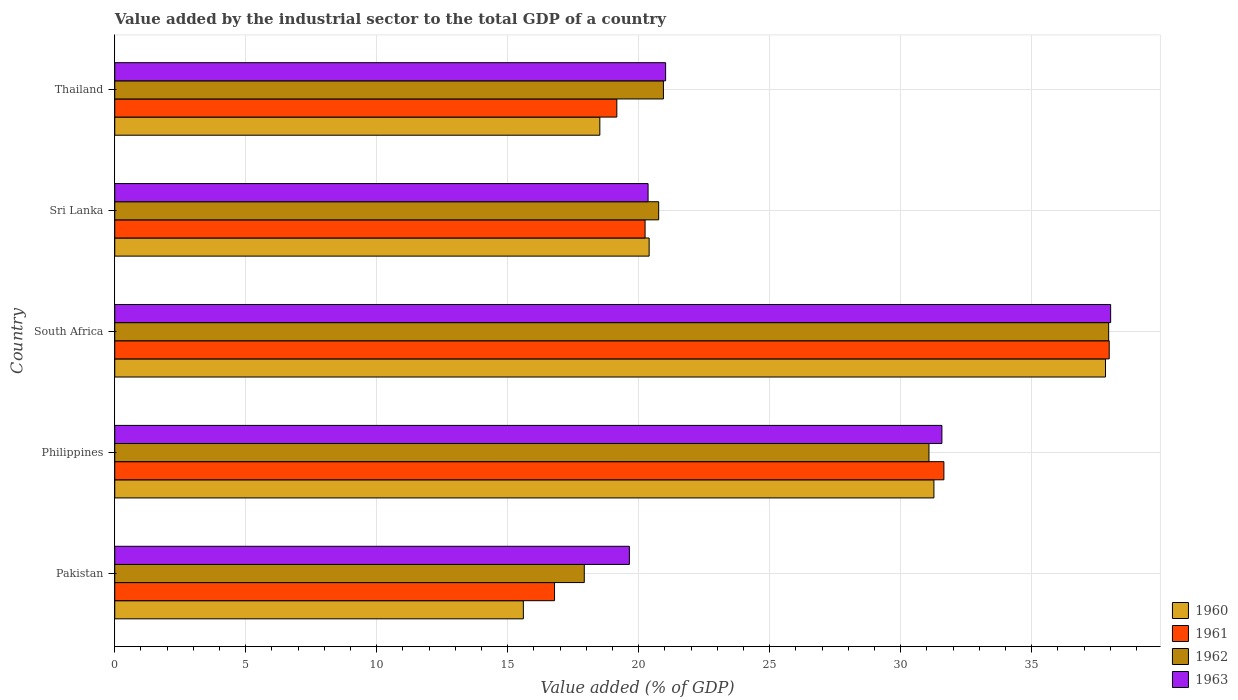How many different coloured bars are there?
Provide a succinct answer. 4. How many groups of bars are there?
Your answer should be compact. 5. Are the number of bars per tick equal to the number of legend labels?
Give a very brief answer. Yes. How many bars are there on the 3rd tick from the top?
Give a very brief answer. 4. How many bars are there on the 3rd tick from the bottom?
Keep it short and to the point. 4. What is the value added by the industrial sector to the total GDP in 1962 in Thailand?
Your answer should be very brief. 20.94. Across all countries, what is the maximum value added by the industrial sector to the total GDP in 1960?
Your response must be concise. 37.82. Across all countries, what is the minimum value added by the industrial sector to the total GDP in 1963?
Your answer should be very brief. 19.64. In which country was the value added by the industrial sector to the total GDP in 1962 maximum?
Offer a terse response. South Africa. In which country was the value added by the industrial sector to the total GDP in 1960 minimum?
Your response must be concise. Pakistan. What is the total value added by the industrial sector to the total GDP in 1962 in the graph?
Your answer should be compact. 128.64. What is the difference between the value added by the industrial sector to the total GDP in 1961 in Pakistan and that in Sri Lanka?
Provide a short and direct response. -3.46. What is the difference between the value added by the industrial sector to the total GDP in 1960 in Thailand and the value added by the industrial sector to the total GDP in 1962 in Pakistan?
Make the answer very short. 0.59. What is the average value added by the industrial sector to the total GDP in 1963 per country?
Provide a succinct answer. 26.12. What is the difference between the value added by the industrial sector to the total GDP in 1961 and value added by the industrial sector to the total GDP in 1960 in Pakistan?
Make the answer very short. 1.19. What is the ratio of the value added by the industrial sector to the total GDP in 1962 in Pakistan to that in Sri Lanka?
Offer a terse response. 0.86. Is the value added by the industrial sector to the total GDP in 1960 in South Africa less than that in Sri Lanka?
Make the answer very short. No. What is the difference between the highest and the second highest value added by the industrial sector to the total GDP in 1960?
Ensure brevity in your answer.  6.55. What is the difference between the highest and the lowest value added by the industrial sector to the total GDP in 1962?
Give a very brief answer. 20.02. Is it the case that in every country, the sum of the value added by the industrial sector to the total GDP in 1962 and value added by the industrial sector to the total GDP in 1963 is greater than the sum of value added by the industrial sector to the total GDP in 1961 and value added by the industrial sector to the total GDP in 1960?
Ensure brevity in your answer.  No. What does the 1st bar from the top in Thailand represents?
Your response must be concise. 1963. What does the 1st bar from the bottom in Thailand represents?
Give a very brief answer. 1960. Is it the case that in every country, the sum of the value added by the industrial sector to the total GDP in 1961 and value added by the industrial sector to the total GDP in 1960 is greater than the value added by the industrial sector to the total GDP in 1962?
Give a very brief answer. Yes. Are all the bars in the graph horizontal?
Provide a succinct answer. Yes. Are the values on the major ticks of X-axis written in scientific E-notation?
Make the answer very short. No. How many legend labels are there?
Make the answer very short. 4. How are the legend labels stacked?
Provide a succinct answer. Vertical. What is the title of the graph?
Your answer should be compact. Value added by the industrial sector to the total GDP of a country. Does "2012" appear as one of the legend labels in the graph?
Keep it short and to the point. No. What is the label or title of the X-axis?
Your response must be concise. Value added (% of GDP). What is the Value added (% of GDP) in 1960 in Pakistan?
Provide a short and direct response. 15.6. What is the Value added (% of GDP) in 1961 in Pakistan?
Your answer should be compact. 16.79. What is the Value added (% of GDP) in 1962 in Pakistan?
Your answer should be compact. 17.92. What is the Value added (% of GDP) in 1963 in Pakistan?
Ensure brevity in your answer.  19.64. What is the Value added (% of GDP) of 1960 in Philippines?
Keep it short and to the point. 31.27. What is the Value added (% of GDP) in 1961 in Philippines?
Offer a very short reply. 31.65. What is the Value added (% of GDP) in 1962 in Philippines?
Provide a succinct answer. 31.08. What is the Value added (% of GDP) of 1963 in Philippines?
Ensure brevity in your answer.  31.57. What is the Value added (% of GDP) in 1960 in South Africa?
Offer a very short reply. 37.82. What is the Value added (% of GDP) of 1961 in South Africa?
Give a very brief answer. 37.96. What is the Value added (% of GDP) of 1962 in South Africa?
Keep it short and to the point. 37.94. What is the Value added (% of GDP) of 1963 in South Africa?
Your answer should be compact. 38.01. What is the Value added (% of GDP) in 1960 in Sri Lanka?
Your answer should be compact. 20.4. What is the Value added (% of GDP) in 1961 in Sri Lanka?
Offer a very short reply. 20.24. What is the Value added (% of GDP) of 1962 in Sri Lanka?
Make the answer very short. 20.76. What is the Value added (% of GDP) of 1963 in Sri Lanka?
Your answer should be compact. 20.36. What is the Value added (% of GDP) of 1960 in Thailand?
Keep it short and to the point. 18.52. What is the Value added (% of GDP) of 1961 in Thailand?
Your response must be concise. 19.16. What is the Value added (% of GDP) of 1962 in Thailand?
Provide a succinct answer. 20.94. What is the Value added (% of GDP) of 1963 in Thailand?
Provide a short and direct response. 21.03. Across all countries, what is the maximum Value added (% of GDP) of 1960?
Your answer should be very brief. 37.82. Across all countries, what is the maximum Value added (% of GDP) in 1961?
Your answer should be very brief. 37.96. Across all countries, what is the maximum Value added (% of GDP) of 1962?
Keep it short and to the point. 37.94. Across all countries, what is the maximum Value added (% of GDP) in 1963?
Give a very brief answer. 38.01. Across all countries, what is the minimum Value added (% of GDP) in 1960?
Keep it short and to the point. 15.6. Across all countries, what is the minimum Value added (% of GDP) in 1961?
Make the answer very short. 16.79. Across all countries, what is the minimum Value added (% of GDP) in 1962?
Give a very brief answer. 17.92. Across all countries, what is the minimum Value added (% of GDP) in 1963?
Keep it short and to the point. 19.64. What is the total Value added (% of GDP) in 1960 in the graph?
Ensure brevity in your answer.  123.6. What is the total Value added (% of GDP) of 1961 in the graph?
Your response must be concise. 125.8. What is the total Value added (% of GDP) of 1962 in the graph?
Your answer should be very brief. 128.64. What is the total Value added (% of GDP) in 1963 in the graph?
Provide a short and direct response. 130.62. What is the difference between the Value added (% of GDP) of 1960 in Pakistan and that in Philippines?
Make the answer very short. -15.67. What is the difference between the Value added (% of GDP) in 1961 in Pakistan and that in Philippines?
Keep it short and to the point. -14.86. What is the difference between the Value added (% of GDP) in 1962 in Pakistan and that in Philippines?
Offer a very short reply. -13.16. What is the difference between the Value added (% of GDP) of 1963 in Pakistan and that in Philippines?
Ensure brevity in your answer.  -11.93. What is the difference between the Value added (% of GDP) in 1960 in Pakistan and that in South Africa?
Provide a short and direct response. -22.22. What is the difference between the Value added (% of GDP) in 1961 in Pakistan and that in South Africa?
Keep it short and to the point. -21.17. What is the difference between the Value added (% of GDP) of 1962 in Pakistan and that in South Africa?
Your answer should be compact. -20.02. What is the difference between the Value added (% of GDP) in 1963 in Pakistan and that in South Africa?
Make the answer very short. -18.37. What is the difference between the Value added (% of GDP) of 1960 in Pakistan and that in Sri Lanka?
Your answer should be very brief. -4.8. What is the difference between the Value added (% of GDP) in 1961 in Pakistan and that in Sri Lanka?
Provide a short and direct response. -3.46. What is the difference between the Value added (% of GDP) of 1962 in Pakistan and that in Sri Lanka?
Your response must be concise. -2.84. What is the difference between the Value added (% of GDP) in 1963 in Pakistan and that in Sri Lanka?
Offer a terse response. -0.71. What is the difference between the Value added (% of GDP) in 1960 in Pakistan and that in Thailand?
Your answer should be very brief. -2.92. What is the difference between the Value added (% of GDP) in 1961 in Pakistan and that in Thailand?
Ensure brevity in your answer.  -2.38. What is the difference between the Value added (% of GDP) in 1962 in Pakistan and that in Thailand?
Give a very brief answer. -3.02. What is the difference between the Value added (% of GDP) in 1963 in Pakistan and that in Thailand?
Provide a succinct answer. -1.38. What is the difference between the Value added (% of GDP) in 1960 in Philippines and that in South Africa?
Make the answer very short. -6.55. What is the difference between the Value added (% of GDP) in 1961 in Philippines and that in South Africa?
Offer a terse response. -6.31. What is the difference between the Value added (% of GDP) of 1962 in Philippines and that in South Africa?
Offer a terse response. -6.86. What is the difference between the Value added (% of GDP) in 1963 in Philippines and that in South Africa?
Your response must be concise. -6.44. What is the difference between the Value added (% of GDP) of 1960 in Philippines and that in Sri Lanka?
Offer a terse response. 10.87. What is the difference between the Value added (% of GDP) of 1961 in Philippines and that in Sri Lanka?
Ensure brevity in your answer.  11.41. What is the difference between the Value added (% of GDP) in 1962 in Philippines and that in Sri Lanka?
Your response must be concise. 10.32. What is the difference between the Value added (% of GDP) of 1963 in Philippines and that in Sri Lanka?
Make the answer very short. 11.22. What is the difference between the Value added (% of GDP) of 1960 in Philippines and that in Thailand?
Offer a very short reply. 12.75. What is the difference between the Value added (% of GDP) of 1961 in Philippines and that in Thailand?
Your answer should be compact. 12.48. What is the difference between the Value added (% of GDP) in 1962 in Philippines and that in Thailand?
Make the answer very short. 10.14. What is the difference between the Value added (% of GDP) in 1963 in Philippines and that in Thailand?
Ensure brevity in your answer.  10.55. What is the difference between the Value added (% of GDP) of 1960 in South Africa and that in Sri Lanka?
Ensure brevity in your answer.  17.42. What is the difference between the Value added (% of GDP) in 1961 in South Africa and that in Sri Lanka?
Make the answer very short. 17.72. What is the difference between the Value added (% of GDP) in 1962 in South Africa and that in Sri Lanka?
Offer a terse response. 17.18. What is the difference between the Value added (% of GDP) in 1963 in South Africa and that in Sri Lanka?
Keep it short and to the point. 17.66. What is the difference between the Value added (% of GDP) in 1960 in South Africa and that in Thailand?
Provide a short and direct response. 19.3. What is the difference between the Value added (% of GDP) in 1961 in South Africa and that in Thailand?
Make the answer very short. 18.79. What is the difference between the Value added (% of GDP) in 1962 in South Africa and that in Thailand?
Your response must be concise. 17. What is the difference between the Value added (% of GDP) in 1963 in South Africa and that in Thailand?
Your answer should be very brief. 16.99. What is the difference between the Value added (% of GDP) of 1960 in Sri Lanka and that in Thailand?
Provide a short and direct response. 1.88. What is the difference between the Value added (% of GDP) of 1961 in Sri Lanka and that in Thailand?
Make the answer very short. 1.08. What is the difference between the Value added (% of GDP) in 1962 in Sri Lanka and that in Thailand?
Your answer should be very brief. -0.18. What is the difference between the Value added (% of GDP) in 1963 in Sri Lanka and that in Thailand?
Keep it short and to the point. -0.67. What is the difference between the Value added (% of GDP) of 1960 in Pakistan and the Value added (% of GDP) of 1961 in Philippines?
Provide a short and direct response. -16.05. What is the difference between the Value added (% of GDP) of 1960 in Pakistan and the Value added (% of GDP) of 1962 in Philippines?
Offer a very short reply. -15.48. What is the difference between the Value added (% of GDP) in 1960 in Pakistan and the Value added (% of GDP) in 1963 in Philippines?
Your answer should be very brief. -15.98. What is the difference between the Value added (% of GDP) in 1961 in Pakistan and the Value added (% of GDP) in 1962 in Philippines?
Ensure brevity in your answer.  -14.29. What is the difference between the Value added (% of GDP) of 1961 in Pakistan and the Value added (% of GDP) of 1963 in Philippines?
Your answer should be compact. -14.79. What is the difference between the Value added (% of GDP) of 1962 in Pakistan and the Value added (% of GDP) of 1963 in Philippines?
Your answer should be compact. -13.65. What is the difference between the Value added (% of GDP) of 1960 in Pakistan and the Value added (% of GDP) of 1961 in South Africa?
Offer a terse response. -22.36. What is the difference between the Value added (% of GDP) in 1960 in Pakistan and the Value added (% of GDP) in 1962 in South Africa?
Your answer should be compact. -22.34. What is the difference between the Value added (% of GDP) in 1960 in Pakistan and the Value added (% of GDP) in 1963 in South Africa?
Your answer should be very brief. -22.42. What is the difference between the Value added (% of GDP) of 1961 in Pakistan and the Value added (% of GDP) of 1962 in South Africa?
Make the answer very short. -21.15. What is the difference between the Value added (% of GDP) of 1961 in Pakistan and the Value added (% of GDP) of 1963 in South Africa?
Provide a succinct answer. -21.23. What is the difference between the Value added (% of GDP) of 1962 in Pakistan and the Value added (% of GDP) of 1963 in South Africa?
Give a very brief answer. -20.09. What is the difference between the Value added (% of GDP) in 1960 in Pakistan and the Value added (% of GDP) in 1961 in Sri Lanka?
Make the answer very short. -4.65. What is the difference between the Value added (% of GDP) in 1960 in Pakistan and the Value added (% of GDP) in 1962 in Sri Lanka?
Give a very brief answer. -5.16. What is the difference between the Value added (% of GDP) of 1960 in Pakistan and the Value added (% of GDP) of 1963 in Sri Lanka?
Your response must be concise. -4.76. What is the difference between the Value added (% of GDP) of 1961 in Pakistan and the Value added (% of GDP) of 1962 in Sri Lanka?
Your answer should be very brief. -3.97. What is the difference between the Value added (% of GDP) in 1961 in Pakistan and the Value added (% of GDP) in 1963 in Sri Lanka?
Make the answer very short. -3.57. What is the difference between the Value added (% of GDP) of 1962 in Pakistan and the Value added (% of GDP) of 1963 in Sri Lanka?
Offer a very short reply. -2.44. What is the difference between the Value added (% of GDP) of 1960 in Pakistan and the Value added (% of GDP) of 1961 in Thailand?
Give a very brief answer. -3.57. What is the difference between the Value added (% of GDP) in 1960 in Pakistan and the Value added (% of GDP) in 1962 in Thailand?
Your response must be concise. -5.35. What is the difference between the Value added (% of GDP) of 1960 in Pakistan and the Value added (% of GDP) of 1963 in Thailand?
Your response must be concise. -5.43. What is the difference between the Value added (% of GDP) in 1961 in Pakistan and the Value added (% of GDP) in 1962 in Thailand?
Offer a very short reply. -4.16. What is the difference between the Value added (% of GDP) in 1961 in Pakistan and the Value added (% of GDP) in 1963 in Thailand?
Your answer should be compact. -4.24. What is the difference between the Value added (% of GDP) of 1962 in Pakistan and the Value added (% of GDP) of 1963 in Thailand?
Provide a succinct answer. -3.11. What is the difference between the Value added (% of GDP) of 1960 in Philippines and the Value added (% of GDP) of 1961 in South Africa?
Offer a very short reply. -6.69. What is the difference between the Value added (% of GDP) of 1960 in Philippines and the Value added (% of GDP) of 1962 in South Africa?
Provide a succinct answer. -6.67. What is the difference between the Value added (% of GDP) in 1960 in Philippines and the Value added (% of GDP) in 1963 in South Africa?
Your response must be concise. -6.75. What is the difference between the Value added (% of GDP) of 1961 in Philippines and the Value added (% of GDP) of 1962 in South Africa?
Your response must be concise. -6.29. What is the difference between the Value added (% of GDP) in 1961 in Philippines and the Value added (% of GDP) in 1963 in South Africa?
Provide a succinct answer. -6.37. What is the difference between the Value added (% of GDP) of 1962 in Philippines and the Value added (% of GDP) of 1963 in South Africa?
Offer a terse response. -6.93. What is the difference between the Value added (% of GDP) of 1960 in Philippines and the Value added (% of GDP) of 1961 in Sri Lanka?
Make the answer very short. 11.03. What is the difference between the Value added (% of GDP) of 1960 in Philippines and the Value added (% of GDP) of 1962 in Sri Lanka?
Provide a succinct answer. 10.51. What is the difference between the Value added (% of GDP) of 1960 in Philippines and the Value added (% of GDP) of 1963 in Sri Lanka?
Offer a very short reply. 10.91. What is the difference between the Value added (% of GDP) of 1961 in Philippines and the Value added (% of GDP) of 1962 in Sri Lanka?
Offer a terse response. 10.89. What is the difference between the Value added (% of GDP) of 1961 in Philippines and the Value added (% of GDP) of 1963 in Sri Lanka?
Your answer should be very brief. 11.29. What is the difference between the Value added (% of GDP) in 1962 in Philippines and the Value added (% of GDP) in 1963 in Sri Lanka?
Ensure brevity in your answer.  10.72. What is the difference between the Value added (% of GDP) in 1960 in Philippines and the Value added (% of GDP) in 1961 in Thailand?
Provide a succinct answer. 12.1. What is the difference between the Value added (% of GDP) of 1960 in Philippines and the Value added (% of GDP) of 1962 in Thailand?
Provide a succinct answer. 10.33. What is the difference between the Value added (% of GDP) of 1960 in Philippines and the Value added (% of GDP) of 1963 in Thailand?
Offer a very short reply. 10.24. What is the difference between the Value added (% of GDP) in 1961 in Philippines and the Value added (% of GDP) in 1962 in Thailand?
Make the answer very short. 10.71. What is the difference between the Value added (% of GDP) in 1961 in Philippines and the Value added (% of GDP) in 1963 in Thailand?
Ensure brevity in your answer.  10.62. What is the difference between the Value added (% of GDP) in 1962 in Philippines and the Value added (% of GDP) in 1963 in Thailand?
Your response must be concise. 10.05. What is the difference between the Value added (% of GDP) in 1960 in South Africa and the Value added (% of GDP) in 1961 in Sri Lanka?
Ensure brevity in your answer.  17.57. What is the difference between the Value added (% of GDP) in 1960 in South Africa and the Value added (% of GDP) in 1962 in Sri Lanka?
Give a very brief answer. 17.06. What is the difference between the Value added (% of GDP) in 1960 in South Africa and the Value added (% of GDP) in 1963 in Sri Lanka?
Provide a succinct answer. 17.46. What is the difference between the Value added (% of GDP) in 1961 in South Africa and the Value added (% of GDP) in 1962 in Sri Lanka?
Make the answer very short. 17.2. What is the difference between the Value added (% of GDP) of 1961 in South Africa and the Value added (% of GDP) of 1963 in Sri Lanka?
Ensure brevity in your answer.  17.6. What is the difference between the Value added (% of GDP) in 1962 in South Africa and the Value added (% of GDP) in 1963 in Sri Lanka?
Your answer should be compact. 17.58. What is the difference between the Value added (% of GDP) of 1960 in South Africa and the Value added (% of GDP) of 1961 in Thailand?
Offer a terse response. 18.65. What is the difference between the Value added (% of GDP) in 1960 in South Africa and the Value added (% of GDP) in 1962 in Thailand?
Ensure brevity in your answer.  16.87. What is the difference between the Value added (% of GDP) in 1960 in South Africa and the Value added (% of GDP) in 1963 in Thailand?
Your answer should be very brief. 16.79. What is the difference between the Value added (% of GDP) of 1961 in South Africa and the Value added (% of GDP) of 1962 in Thailand?
Provide a short and direct response. 17.02. What is the difference between the Value added (% of GDP) of 1961 in South Africa and the Value added (% of GDP) of 1963 in Thailand?
Your response must be concise. 16.93. What is the difference between the Value added (% of GDP) of 1962 in South Africa and the Value added (% of GDP) of 1963 in Thailand?
Your answer should be very brief. 16.91. What is the difference between the Value added (% of GDP) of 1960 in Sri Lanka and the Value added (% of GDP) of 1961 in Thailand?
Make the answer very short. 1.23. What is the difference between the Value added (% of GDP) in 1960 in Sri Lanka and the Value added (% of GDP) in 1962 in Thailand?
Make the answer very short. -0.54. What is the difference between the Value added (% of GDP) of 1960 in Sri Lanka and the Value added (% of GDP) of 1963 in Thailand?
Offer a terse response. -0.63. What is the difference between the Value added (% of GDP) of 1961 in Sri Lanka and the Value added (% of GDP) of 1962 in Thailand?
Your answer should be very brief. -0.7. What is the difference between the Value added (% of GDP) of 1961 in Sri Lanka and the Value added (% of GDP) of 1963 in Thailand?
Offer a very short reply. -0.78. What is the difference between the Value added (% of GDP) of 1962 in Sri Lanka and the Value added (% of GDP) of 1963 in Thailand?
Provide a succinct answer. -0.27. What is the average Value added (% of GDP) in 1960 per country?
Offer a terse response. 24.72. What is the average Value added (% of GDP) of 1961 per country?
Offer a very short reply. 25.16. What is the average Value added (% of GDP) of 1962 per country?
Provide a succinct answer. 25.73. What is the average Value added (% of GDP) of 1963 per country?
Provide a succinct answer. 26.12. What is the difference between the Value added (% of GDP) of 1960 and Value added (% of GDP) of 1961 in Pakistan?
Your response must be concise. -1.19. What is the difference between the Value added (% of GDP) of 1960 and Value added (% of GDP) of 1962 in Pakistan?
Make the answer very short. -2.33. What is the difference between the Value added (% of GDP) in 1960 and Value added (% of GDP) in 1963 in Pakistan?
Your answer should be very brief. -4.05. What is the difference between the Value added (% of GDP) of 1961 and Value added (% of GDP) of 1962 in Pakistan?
Give a very brief answer. -1.14. What is the difference between the Value added (% of GDP) in 1961 and Value added (% of GDP) in 1963 in Pakistan?
Offer a terse response. -2.86. What is the difference between the Value added (% of GDP) of 1962 and Value added (% of GDP) of 1963 in Pakistan?
Ensure brevity in your answer.  -1.72. What is the difference between the Value added (% of GDP) in 1960 and Value added (% of GDP) in 1961 in Philippines?
Your answer should be compact. -0.38. What is the difference between the Value added (% of GDP) of 1960 and Value added (% of GDP) of 1962 in Philippines?
Ensure brevity in your answer.  0.19. What is the difference between the Value added (% of GDP) in 1960 and Value added (% of GDP) in 1963 in Philippines?
Provide a succinct answer. -0.3. What is the difference between the Value added (% of GDP) of 1961 and Value added (% of GDP) of 1962 in Philippines?
Provide a succinct answer. 0.57. What is the difference between the Value added (% of GDP) of 1961 and Value added (% of GDP) of 1963 in Philippines?
Offer a very short reply. 0.08. What is the difference between the Value added (% of GDP) in 1962 and Value added (% of GDP) in 1963 in Philippines?
Ensure brevity in your answer.  -0.49. What is the difference between the Value added (% of GDP) in 1960 and Value added (% of GDP) in 1961 in South Africa?
Ensure brevity in your answer.  -0.14. What is the difference between the Value added (% of GDP) of 1960 and Value added (% of GDP) of 1962 in South Africa?
Ensure brevity in your answer.  -0.12. What is the difference between the Value added (% of GDP) in 1960 and Value added (% of GDP) in 1963 in South Africa?
Your response must be concise. -0.2. What is the difference between the Value added (% of GDP) of 1961 and Value added (% of GDP) of 1962 in South Africa?
Give a very brief answer. 0.02. What is the difference between the Value added (% of GDP) of 1961 and Value added (% of GDP) of 1963 in South Africa?
Make the answer very short. -0.05. What is the difference between the Value added (% of GDP) in 1962 and Value added (% of GDP) in 1963 in South Africa?
Provide a succinct answer. -0.08. What is the difference between the Value added (% of GDP) in 1960 and Value added (% of GDP) in 1961 in Sri Lanka?
Your answer should be very brief. 0.16. What is the difference between the Value added (% of GDP) in 1960 and Value added (% of GDP) in 1962 in Sri Lanka?
Offer a terse response. -0.36. What is the difference between the Value added (% of GDP) in 1960 and Value added (% of GDP) in 1963 in Sri Lanka?
Ensure brevity in your answer.  0.04. What is the difference between the Value added (% of GDP) in 1961 and Value added (% of GDP) in 1962 in Sri Lanka?
Offer a terse response. -0.52. What is the difference between the Value added (% of GDP) in 1961 and Value added (% of GDP) in 1963 in Sri Lanka?
Your answer should be compact. -0.11. What is the difference between the Value added (% of GDP) in 1962 and Value added (% of GDP) in 1963 in Sri Lanka?
Your response must be concise. 0.4. What is the difference between the Value added (% of GDP) in 1960 and Value added (% of GDP) in 1961 in Thailand?
Your answer should be very brief. -0.65. What is the difference between the Value added (% of GDP) of 1960 and Value added (% of GDP) of 1962 in Thailand?
Give a very brief answer. -2.43. What is the difference between the Value added (% of GDP) in 1960 and Value added (% of GDP) in 1963 in Thailand?
Ensure brevity in your answer.  -2.51. What is the difference between the Value added (% of GDP) of 1961 and Value added (% of GDP) of 1962 in Thailand?
Make the answer very short. -1.78. What is the difference between the Value added (% of GDP) of 1961 and Value added (% of GDP) of 1963 in Thailand?
Your answer should be compact. -1.86. What is the difference between the Value added (% of GDP) of 1962 and Value added (% of GDP) of 1963 in Thailand?
Your answer should be compact. -0.08. What is the ratio of the Value added (% of GDP) of 1960 in Pakistan to that in Philippines?
Offer a terse response. 0.5. What is the ratio of the Value added (% of GDP) in 1961 in Pakistan to that in Philippines?
Offer a very short reply. 0.53. What is the ratio of the Value added (% of GDP) in 1962 in Pakistan to that in Philippines?
Provide a succinct answer. 0.58. What is the ratio of the Value added (% of GDP) in 1963 in Pakistan to that in Philippines?
Your response must be concise. 0.62. What is the ratio of the Value added (% of GDP) of 1960 in Pakistan to that in South Africa?
Your answer should be compact. 0.41. What is the ratio of the Value added (% of GDP) in 1961 in Pakistan to that in South Africa?
Provide a succinct answer. 0.44. What is the ratio of the Value added (% of GDP) in 1962 in Pakistan to that in South Africa?
Provide a succinct answer. 0.47. What is the ratio of the Value added (% of GDP) in 1963 in Pakistan to that in South Africa?
Offer a very short reply. 0.52. What is the ratio of the Value added (% of GDP) of 1960 in Pakistan to that in Sri Lanka?
Your response must be concise. 0.76. What is the ratio of the Value added (% of GDP) in 1961 in Pakistan to that in Sri Lanka?
Your answer should be compact. 0.83. What is the ratio of the Value added (% of GDP) in 1962 in Pakistan to that in Sri Lanka?
Keep it short and to the point. 0.86. What is the ratio of the Value added (% of GDP) of 1963 in Pakistan to that in Sri Lanka?
Offer a very short reply. 0.96. What is the ratio of the Value added (% of GDP) in 1960 in Pakistan to that in Thailand?
Your response must be concise. 0.84. What is the ratio of the Value added (% of GDP) in 1961 in Pakistan to that in Thailand?
Provide a short and direct response. 0.88. What is the ratio of the Value added (% of GDP) in 1962 in Pakistan to that in Thailand?
Your answer should be very brief. 0.86. What is the ratio of the Value added (% of GDP) of 1963 in Pakistan to that in Thailand?
Provide a short and direct response. 0.93. What is the ratio of the Value added (% of GDP) of 1960 in Philippines to that in South Africa?
Your answer should be very brief. 0.83. What is the ratio of the Value added (% of GDP) of 1961 in Philippines to that in South Africa?
Offer a terse response. 0.83. What is the ratio of the Value added (% of GDP) of 1962 in Philippines to that in South Africa?
Provide a short and direct response. 0.82. What is the ratio of the Value added (% of GDP) of 1963 in Philippines to that in South Africa?
Offer a terse response. 0.83. What is the ratio of the Value added (% of GDP) of 1960 in Philippines to that in Sri Lanka?
Offer a very short reply. 1.53. What is the ratio of the Value added (% of GDP) in 1961 in Philippines to that in Sri Lanka?
Your answer should be very brief. 1.56. What is the ratio of the Value added (% of GDP) in 1962 in Philippines to that in Sri Lanka?
Your answer should be very brief. 1.5. What is the ratio of the Value added (% of GDP) of 1963 in Philippines to that in Sri Lanka?
Your answer should be very brief. 1.55. What is the ratio of the Value added (% of GDP) of 1960 in Philippines to that in Thailand?
Provide a short and direct response. 1.69. What is the ratio of the Value added (% of GDP) of 1961 in Philippines to that in Thailand?
Offer a very short reply. 1.65. What is the ratio of the Value added (% of GDP) in 1962 in Philippines to that in Thailand?
Make the answer very short. 1.48. What is the ratio of the Value added (% of GDP) in 1963 in Philippines to that in Thailand?
Offer a terse response. 1.5. What is the ratio of the Value added (% of GDP) in 1960 in South Africa to that in Sri Lanka?
Ensure brevity in your answer.  1.85. What is the ratio of the Value added (% of GDP) of 1961 in South Africa to that in Sri Lanka?
Give a very brief answer. 1.88. What is the ratio of the Value added (% of GDP) in 1962 in South Africa to that in Sri Lanka?
Provide a succinct answer. 1.83. What is the ratio of the Value added (% of GDP) in 1963 in South Africa to that in Sri Lanka?
Ensure brevity in your answer.  1.87. What is the ratio of the Value added (% of GDP) in 1960 in South Africa to that in Thailand?
Provide a succinct answer. 2.04. What is the ratio of the Value added (% of GDP) of 1961 in South Africa to that in Thailand?
Your response must be concise. 1.98. What is the ratio of the Value added (% of GDP) of 1962 in South Africa to that in Thailand?
Your response must be concise. 1.81. What is the ratio of the Value added (% of GDP) of 1963 in South Africa to that in Thailand?
Your answer should be compact. 1.81. What is the ratio of the Value added (% of GDP) in 1960 in Sri Lanka to that in Thailand?
Your response must be concise. 1.1. What is the ratio of the Value added (% of GDP) in 1961 in Sri Lanka to that in Thailand?
Ensure brevity in your answer.  1.06. What is the ratio of the Value added (% of GDP) in 1962 in Sri Lanka to that in Thailand?
Give a very brief answer. 0.99. What is the ratio of the Value added (% of GDP) of 1963 in Sri Lanka to that in Thailand?
Provide a succinct answer. 0.97. What is the difference between the highest and the second highest Value added (% of GDP) of 1960?
Your answer should be very brief. 6.55. What is the difference between the highest and the second highest Value added (% of GDP) of 1961?
Offer a very short reply. 6.31. What is the difference between the highest and the second highest Value added (% of GDP) in 1962?
Keep it short and to the point. 6.86. What is the difference between the highest and the second highest Value added (% of GDP) in 1963?
Make the answer very short. 6.44. What is the difference between the highest and the lowest Value added (% of GDP) of 1960?
Offer a terse response. 22.22. What is the difference between the highest and the lowest Value added (% of GDP) in 1961?
Give a very brief answer. 21.17. What is the difference between the highest and the lowest Value added (% of GDP) in 1962?
Provide a short and direct response. 20.02. What is the difference between the highest and the lowest Value added (% of GDP) in 1963?
Offer a terse response. 18.37. 